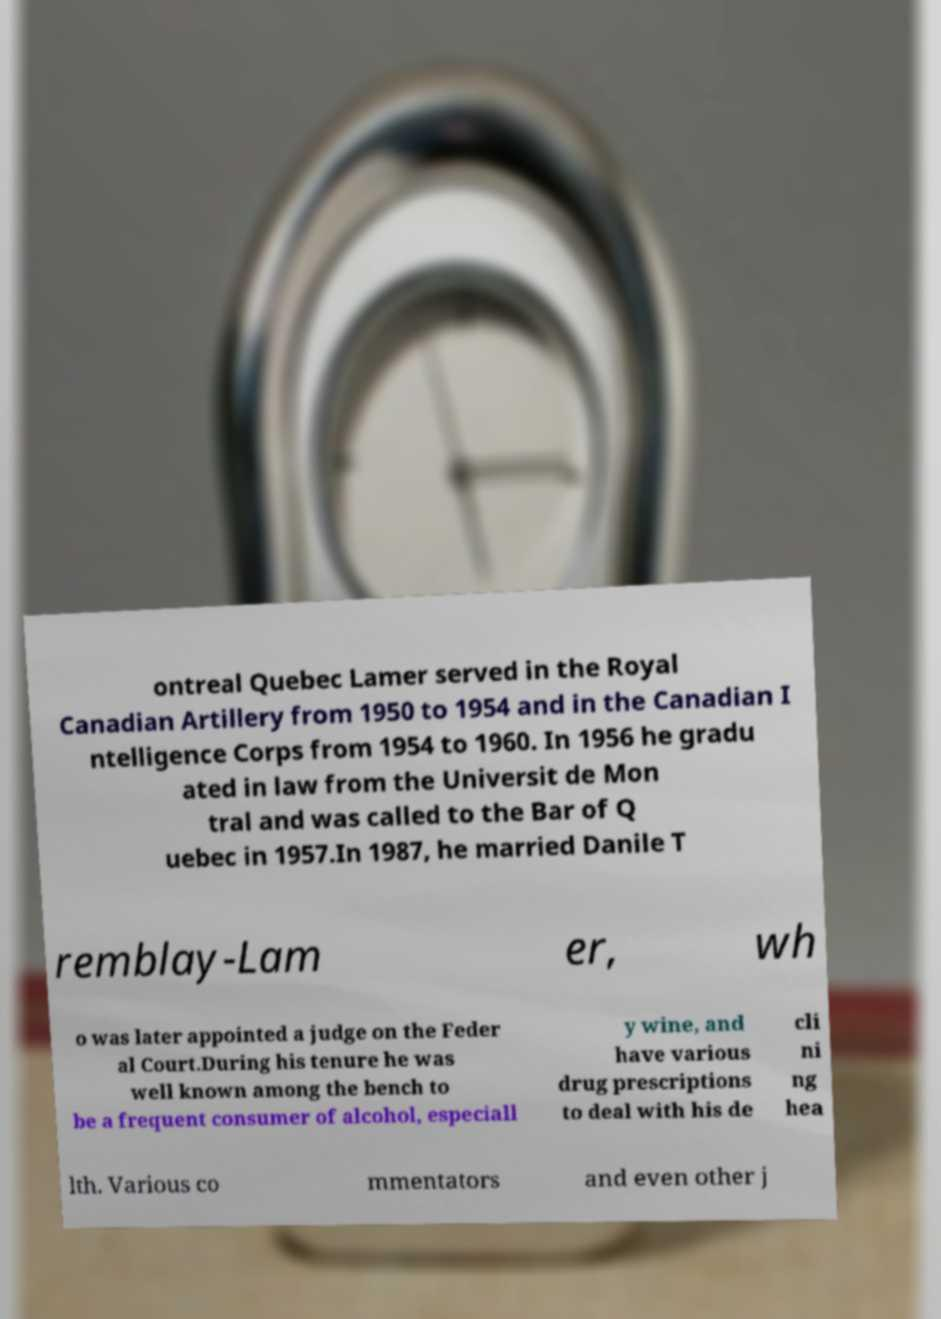What messages or text are displayed in this image? I need them in a readable, typed format. ontreal Quebec Lamer served in the Royal Canadian Artillery from 1950 to 1954 and in the Canadian I ntelligence Corps from 1954 to 1960. In 1956 he gradu ated in law from the Universit de Mon tral and was called to the Bar of Q uebec in 1957.In 1987, he married Danile T remblay-Lam er, wh o was later appointed a judge on the Feder al Court.During his tenure he was well known among the bench to be a frequent consumer of alcohol, especiall y wine, and have various drug prescriptions to deal with his de cli ni ng hea lth. Various co mmentators and even other j 